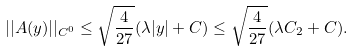Convert formula to latex. <formula><loc_0><loc_0><loc_500><loc_500>| | A ( y ) | | _ { C ^ { 0 } } \leq \sqrt { \frac { 4 } { 2 7 } } ( \lambda | y | + C ) \leq \sqrt { \frac { 4 } { 2 7 } } ( \lambda C _ { 2 } + C ) .</formula> 